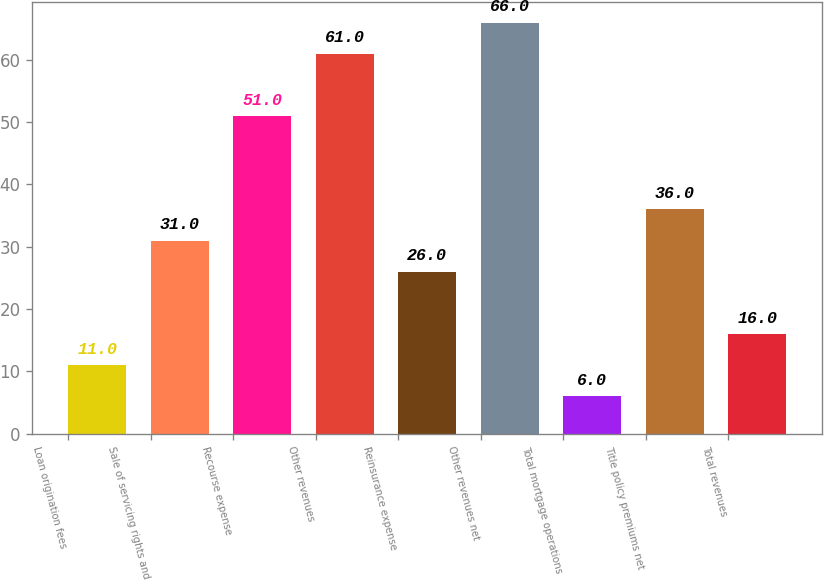Convert chart. <chart><loc_0><loc_0><loc_500><loc_500><bar_chart><fcel>Loan origination fees<fcel>Sale of servicing rights and<fcel>Recourse expense<fcel>Other revenues<fcel>Reinsurance expense<fcel>Other revenues net<fcel>Total mortgage operations<fcel>Title policy premiums net<fcel>Total revenues<nl><fcel>11<fcel>31<fcel>51<fcel>61<fcel>26<fcel>66<fcel>6<fcel>36<fcel>16<nl></chart> 